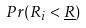Convert formula to latex. <formula><loc_0><loc_0><loc_500><loc_500>P r ( R _ { i } < \underline { R } )</formula> 